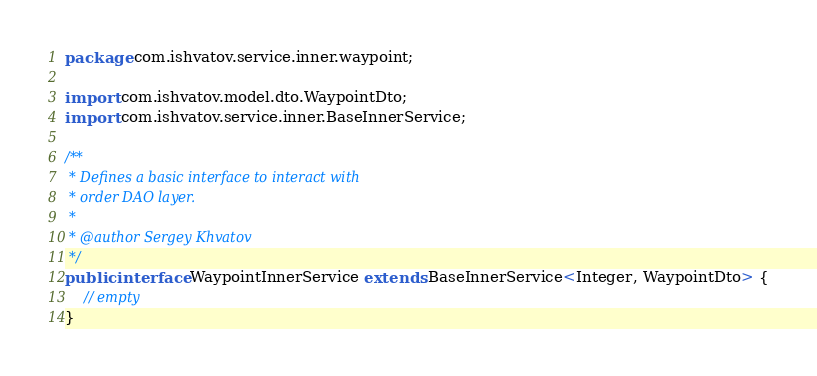<code> <loc_0><loc_0><loc_500><loc_500><_Java_>package com.ishvatov.service.inner.waypoint;

import com.ishvatov.model.dto.WaypointDto;
import com.ishvatov.service.inner.BaseInnerService;

/**
 * Defines a basic interface to interact with
 * order DAO layer.
 *
 * @author Sergey Khvatov
 */
public interface WaypointInnerService extends BaseInnerService<Integer, WaypointDto> {
    // empty
}
</code> 